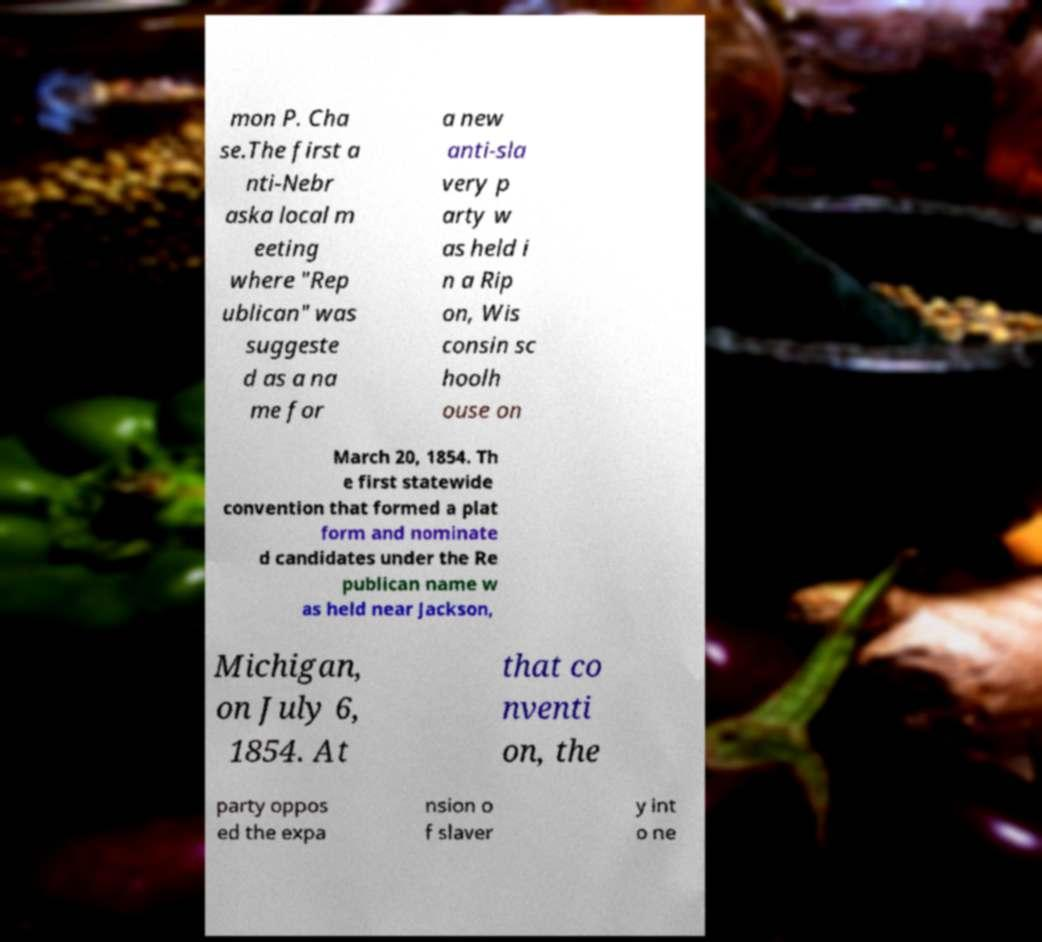There's text embedded in this image that I need extracted. Can you transcribe it verbatim? mon P. Cha se.The first a nti-Nebr aska local m eeting where "Rep ublican" was suggeste d as a na me for a new anti-sla very p arty w as held i n a Rip on, Wis consin sc hoolh ouse on March 20, 1854. Th e first statewide convention that formed a plat form and nominate d candidates under the Re publican name w as held near Jackson, Michigan, on July 6, 1854. At that co nventi on, the party oppos ed the expa nsion o f slaver y int o ne 